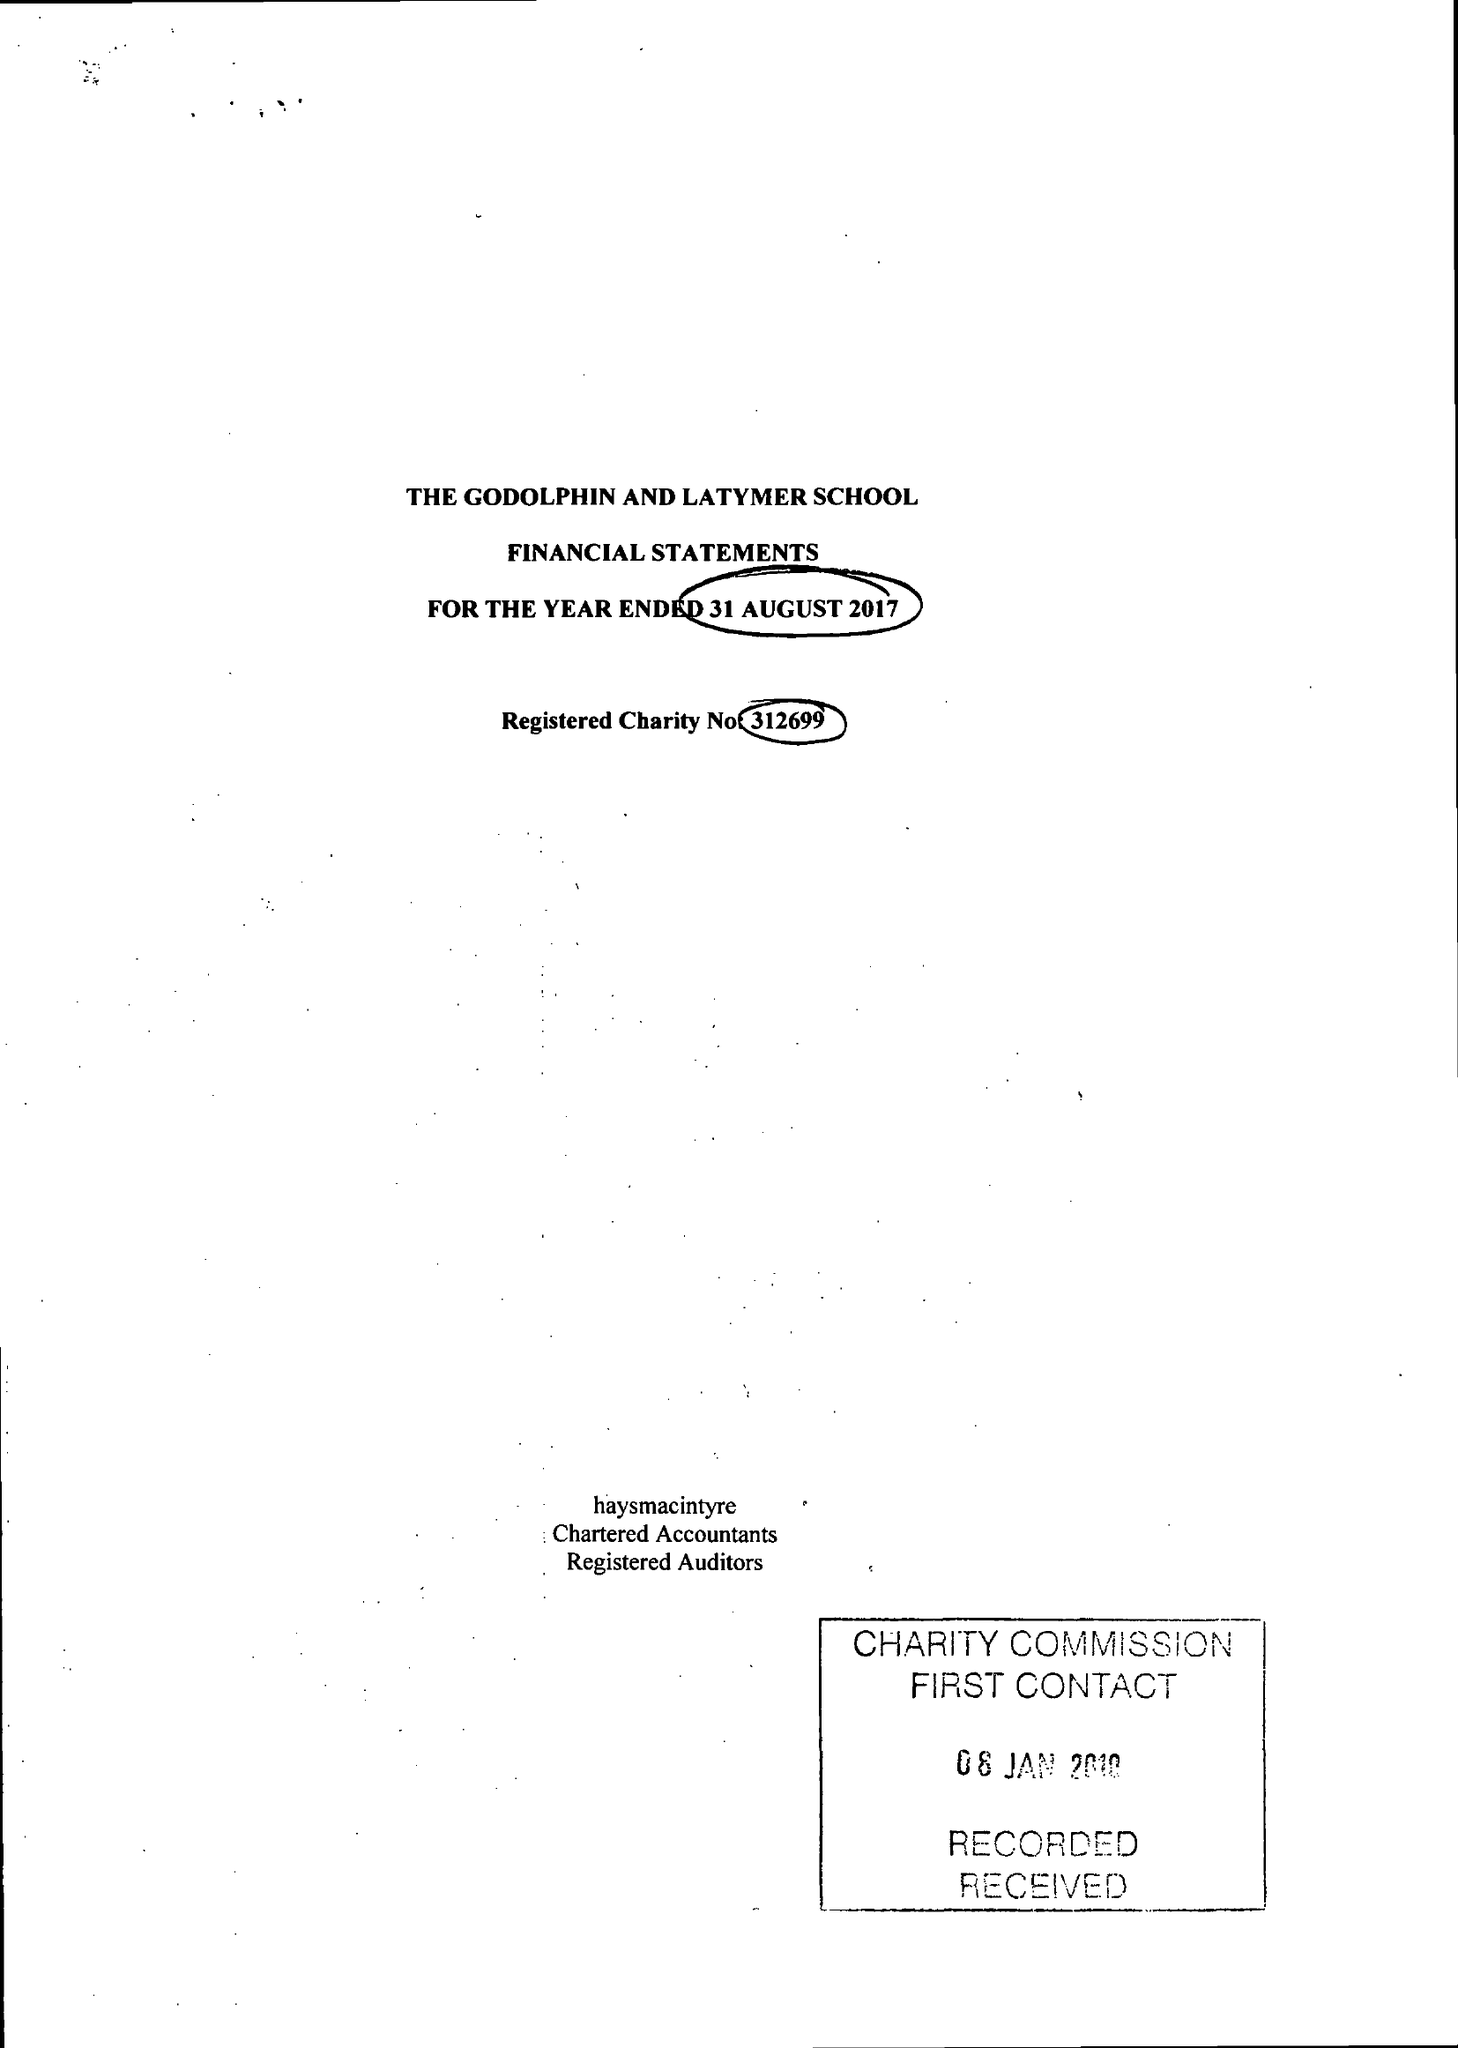What is the value for the address__street_line?
Answer the question using a single word or phrase. IFFLEY ROAD 